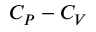<formula> <loc_0><loc_0><loc_500><loc_500>C _ { P } - C _ { V }</formula> 